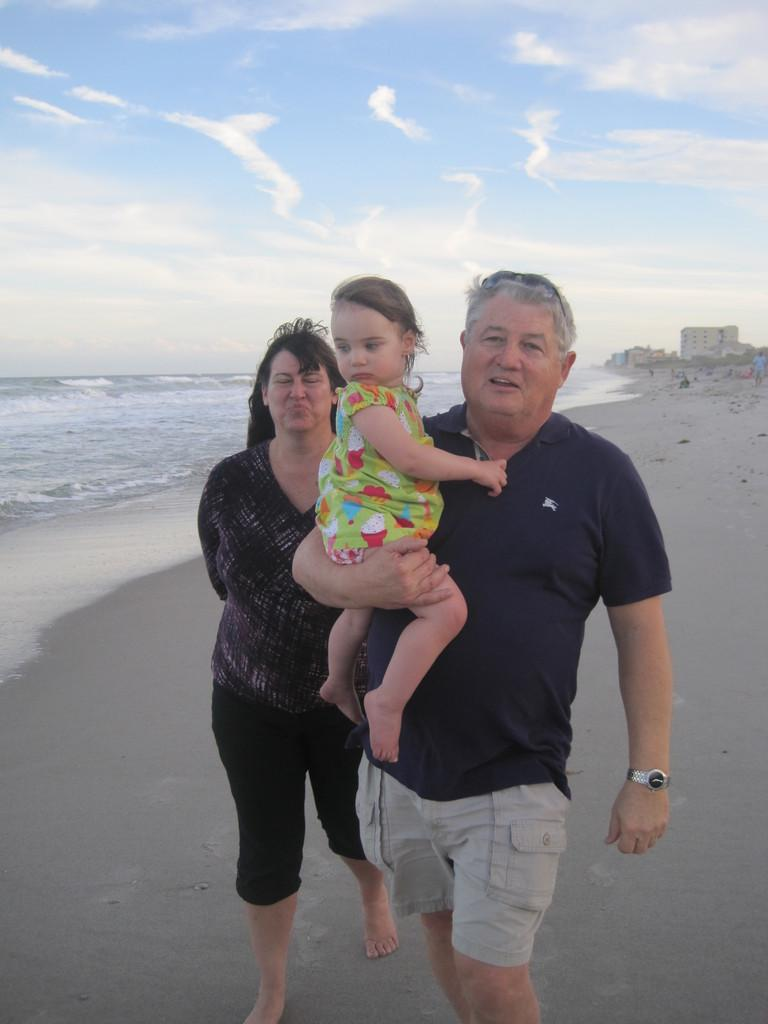How many people are in the image? There are three persons in the image. What can be seen in the background of the image? Buildings and water are visible in the image, and the sky is visible in the background. What is the condition of the sky in the image? The sky is visible in the background, and clouds are present in the sky. How many babies are visible in the image? There are no babies present in the image. What is the desire of the clouds in the image? Clouds do not have desires, as they are inanimate objects. 